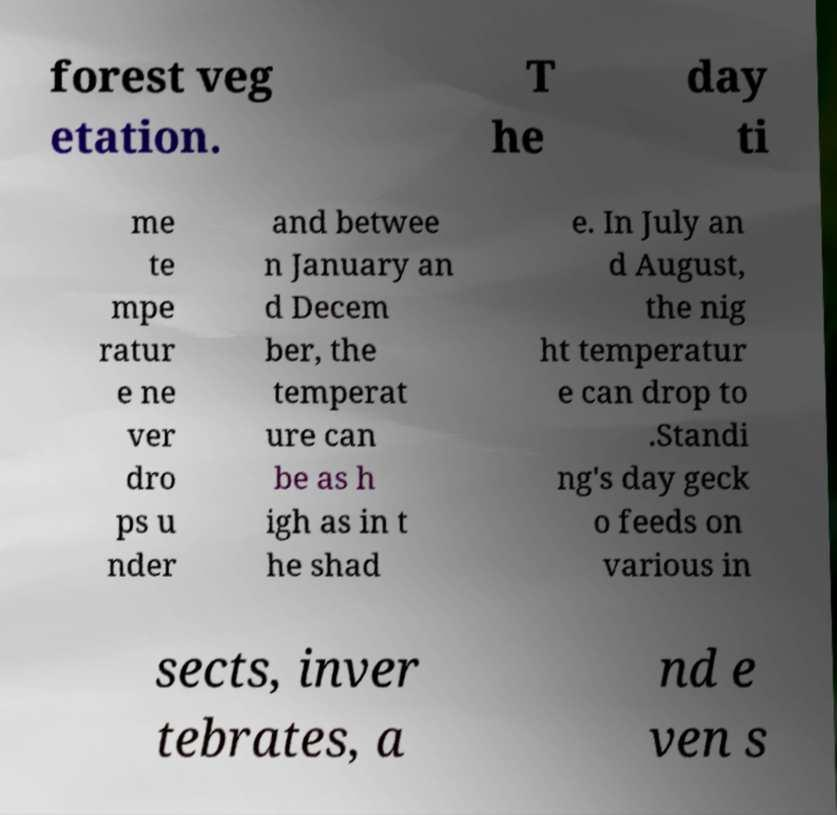What messages or text are displayed in this image? I need them in a readable, typed format. forest veg etation. T he day ti me te mpe ratur e ne ver dro ps u nder and betwee n January an d Decem ber, the temperat ure can be as h igh as in t he shad e. In July an d August, the nig ht temperatur e can drop to .Standi ng's day geck o feeds on various in sects, inver tebrates, a nd e ven s 